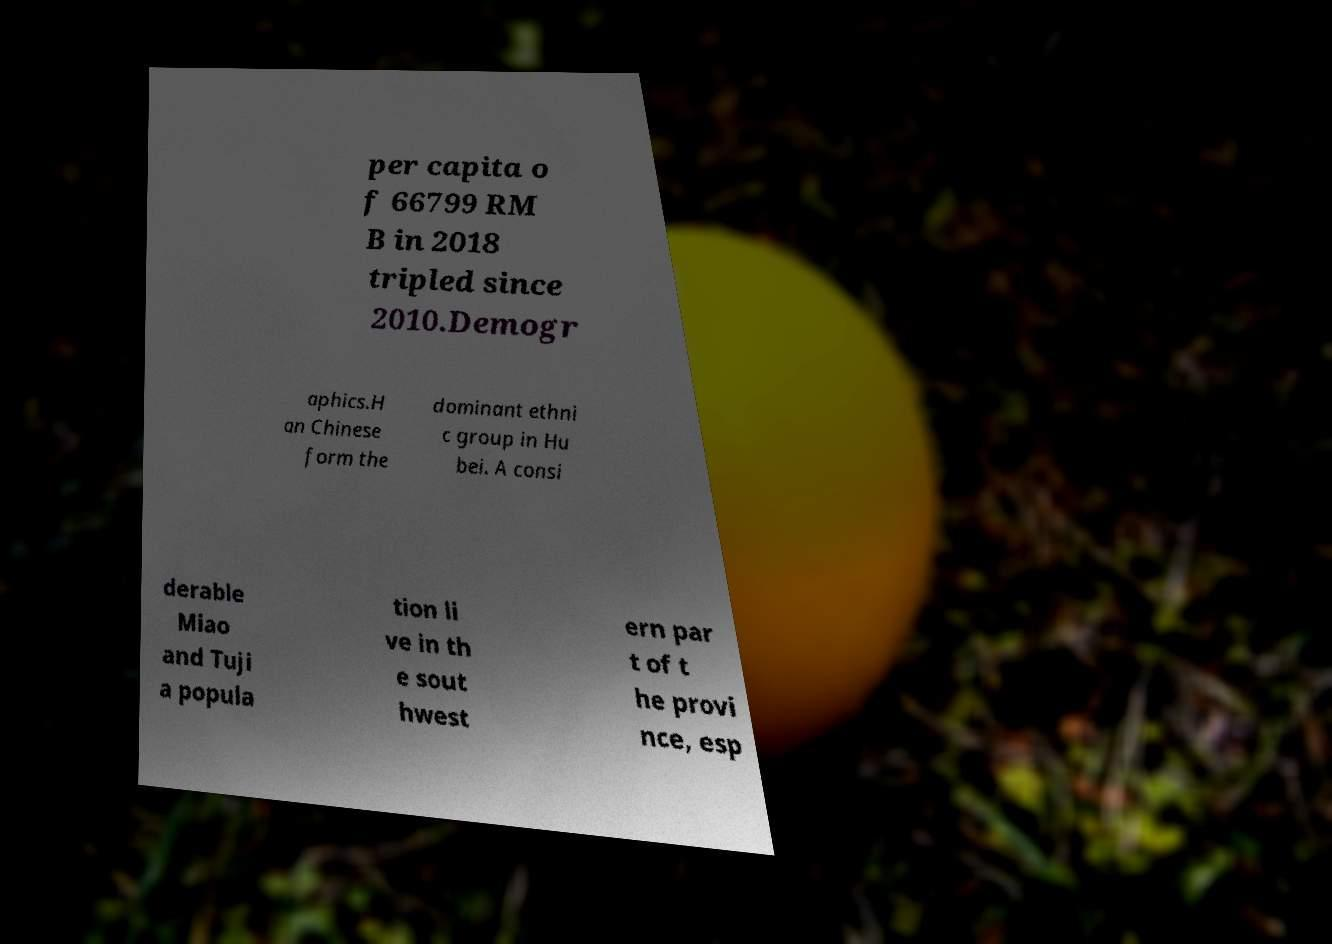Can you accurately transcribe the text from the provided image for me? per capita o f 66799 RM B in 2018 tripled since 2010.Demogr aphics.H an Chinese form the dominant ethni c group in Hu bei. A consi derable Miao and Tuji a popula tion li ve in th e sout hwest ern par t of t he provi nce, esp 